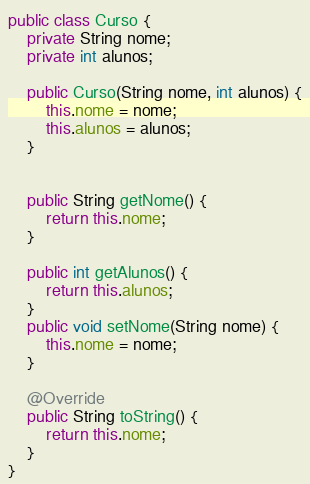<code> <loc_0><loc_0><loc_500><loc_500><_Java_>public class Curso {
	private String nome;
	private int alunos;
	
	public Curso(String nome, int alunos) {
		this.nome = nome;
		this.alunos = alunos;
	}
	
	
	public String getNome() {
		return this.nome;
	}
	
	public int getAlunos() {
		return this.alunos;
	}
	public void setNome(String nome) {
		this.nome = nome;
	}
	
	@Override
	public String toString() {
		return this.nome;
	}
}
</code> 